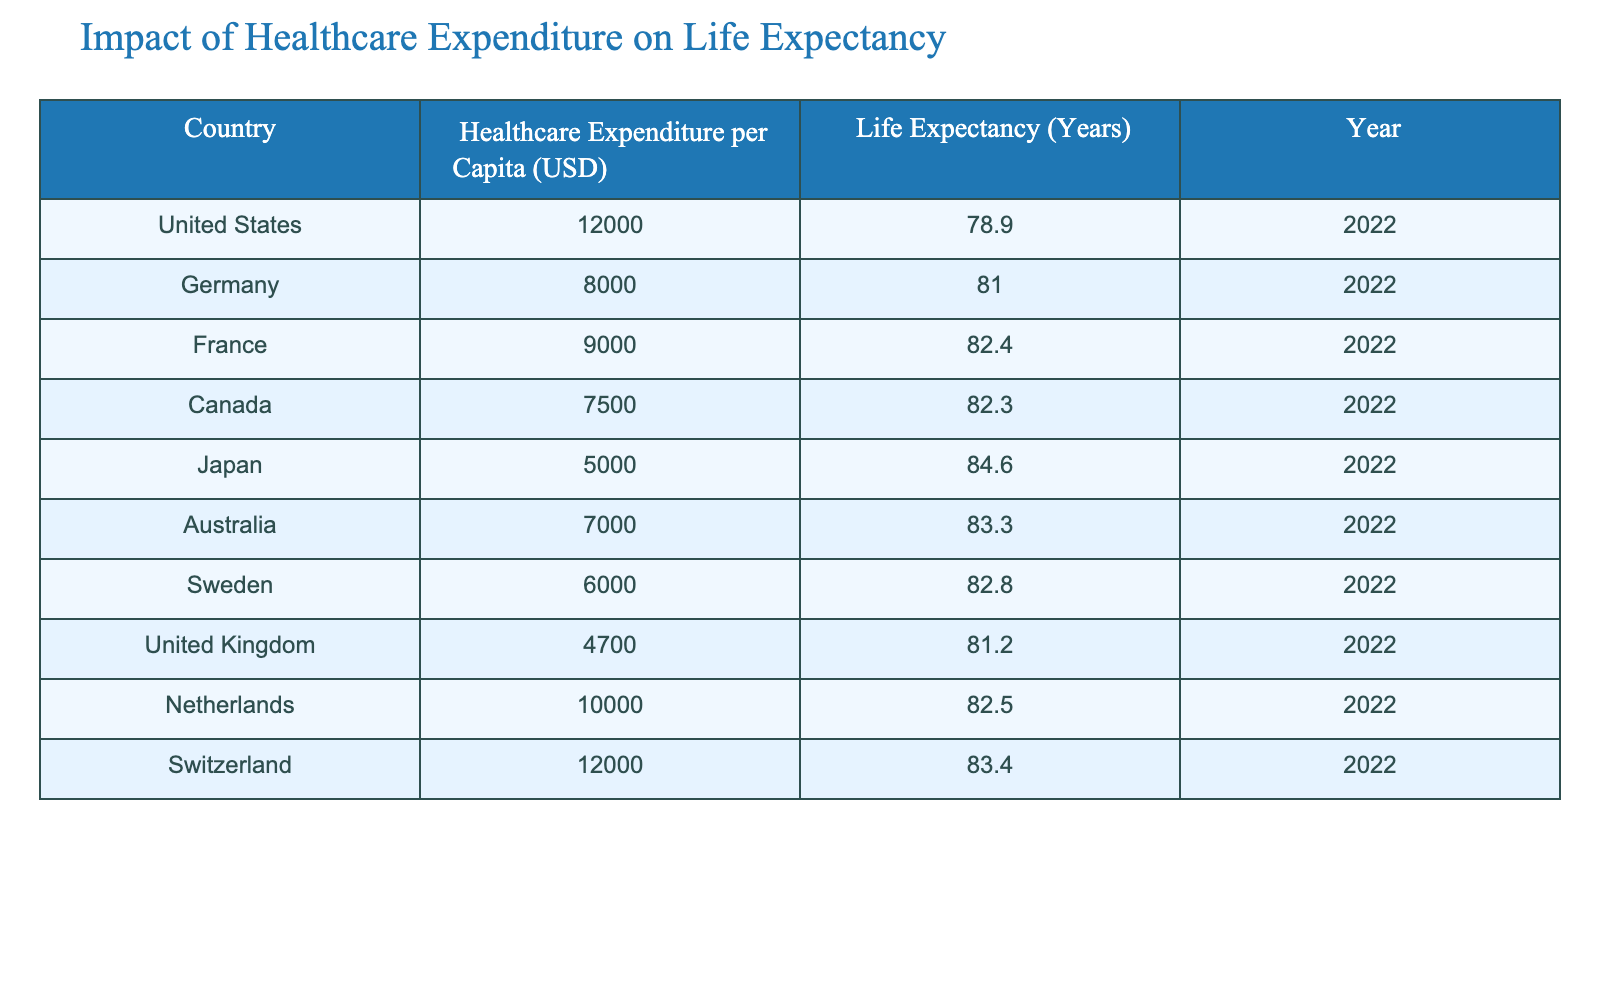What is the life expectancy of the country with the highest healthcare expenditure? The country with the highest healthcare expenditure listed is the United States at 12000 USD. According to the table, the life expectancy of the United States is 78.9 years.
Answer: 78.9 years What is the healthcare expenditure per capita of Japan? According to the table, Japan has a healthcare expenditure per capita of 5000 USD.
Answer: 5000 USD Which country has a life expectancy higher than 82 years? To answer this, we can look at the life expectancy column and find the countries that are above 82 years. The countries with a life expectancy higher than 82 years are France (82.4), Japan (84.6), Australia (83.3), and Switzerland (83.4).
Answer: France, Japan, Australia, Switzerland What is the difference in life expectancy between Germany and Canada? For this question, we start by identifying the life expectancy values for both countries. Germany has a life expectancy of 81.0 years, while Canada has 82.3 years. The difference is calculated as 82.3 - 81.0 = 1.3 years.
Answer: 1.3 years Is the average healthcare expenditure of the countries listed above 8000 USD? We add up the healthcare expenditures: 12000 + 8000 + 9000 + 7500 + 5000 + 7000 + 6000 + 4700 + 10000 + 12000 = 80000 USD. There are 10 countries, so the average is 80000 / 10 = 8000 USD. Yes, the average is indeed 8000 USD.
Answer: Yes Which country has the lowest healthcare expenditure per capita, and what is that value? The table shows the healthcare expenditures per capita for each country. The lowest value is for the United Kingdom, which is at 4700 USD.
Answer: United Kingdom, 4700 USD Are there more countries with life expectancy below 80 years or above 80 years? Let's analyze the life expectancy values: below 80 years: United States (78.9); above 80 years: Germany (81.0), France (82.4), Canada (82.3), Japan (84.6), Australia (83.3), Sweden (82.8), United Kingdom (81.2), Netherlands (82.5), Switzerland (83.4). There is 1 country below 80 years and 9 countries above 80 years. Therefore, there are more countries above 80 years.
Answer: More countries have above 80 years What is the median life expectancy among these countries? To find the median, we first list the life expectancies in order: 78.9, 81.0, 81.2, 82.3, 82.4, 82.5, 82.8, 83.3, 83.4, 84.6. Since there are 10 values, the median will be the average of the 5th and 6th values: (82.4 + 82.5) / 2 = 82.45 years.
Answer: 82.45 years Which country has the closest healthcare expenditure to the Netherlands? The healthcare expenditure per capita for the Netherlands is 10000 USD. The closest value in the list is Germany at 8000 USD, which is a difference of 2000 USD.
Answer: Germany, 8000 USD 